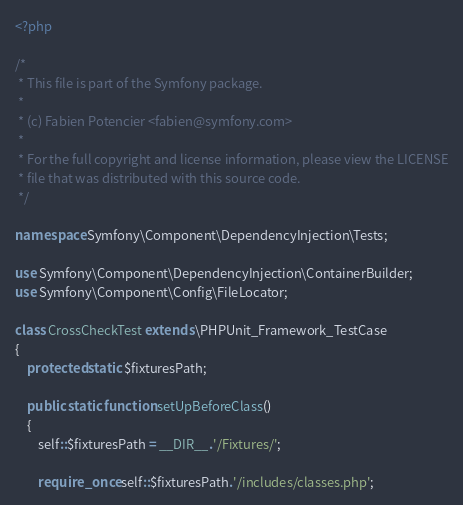<code> <loc_0><loc_0><loc_500><loc_500><_PHP_><?php

/*
 * This file is part of the Symfony package.
 *
 * (c) Fabien Potencier <fabien@symfony.com>
 *
 * For the full copyright and license information, please view the LICENSE
 * file that was distributed with this source code.
 */

namespace Symfony\Component\DependencyInjection\Tests;

use Symfony\Component\DependencyInjection\ContainerBuilder;
use Symfony\Component\Config\FileLocator;

class CrossCheckTest extends \PHPUnit_Framework_TestCase
{
    protected static $fixturesPath;

    public static function setUpBeforeClass()
    {
        self::$fixturesPath = __DIR__.'/Fixtures/';

        require_once self::$fixturesPath.'/includes/classes.php';</code> 